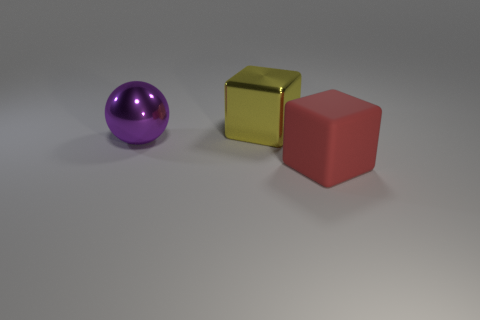How many big rubber cubes have the same color as the large matte thing?
Your answer should be compact. 0. What number of cylinders are either big purple things or large yellow objects?
Offer a very short reply. 0. The big object that is in front of the large yellow metal object and to the left of the red thing has what shape?
Give a very brief answer. Sphere. Is there a purple metallic ball of the same size as the red object?
Ensure brevity in your answer.  Yes. What number of objects are either large metal objects behind the large purple metallic ball or shiny spheres?
Your response must be concise. 2. Is the purple ball made of the same material as the cube on the left side of the red rubber thing?
Provide a short and direct response. Yes. What number of other things are there of the same shape as the purple thing?
Give a very brief answer. 0. What number of objects are big cubes behind the red rubber thing or objects in front of the yellow thing?
Make the answer very short. 3. Are there fewer purple objects in front of the red object than large cubes behind the sphere?
Provide a succinct answer. Yes. What number of red metal things are there?
Your response must be concise. 0. 